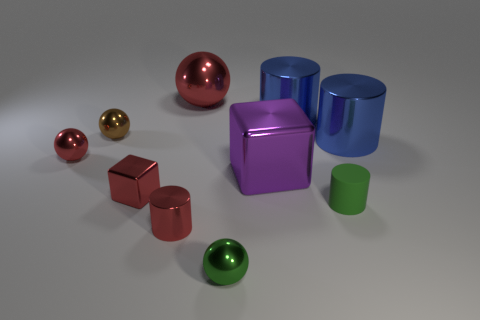Are there any other things that are the same material as the tiny green cylinder?
Make the answer very short. No. Do the small red object to the left of the small block and the tiny ball in front of the red block have the same material?
Your response must be concise. Yes. There is a red shiny ball that is on the right side of the red ball that is in front of the big sphere; how big is it?
Offer a terse response. Large. Is there anything else that is the same size as the purple metal object?
Keep it short and to the point. Yes. There is another object that is the same shape as the purple thing; what material is it?
Provide a short and direct response. Metal. Is the shape of the big blue thing right of the rubber cylinder the same as the small red object that is in front of the matte object?
Your response must be concise. Yes. Are there more green objects than tiny rubber cylinders?
Make the answer very short. Yes. What is the size of the green matte cylinder?
Your answer should be very brief. Small. How many other objects are the same color as the tiny rubber cylinder?
Offer a very short reply. 1. Are the big thing that is on the left side of the large cube and the green cylinder made of the same material?
Give a very brief answer. No. 